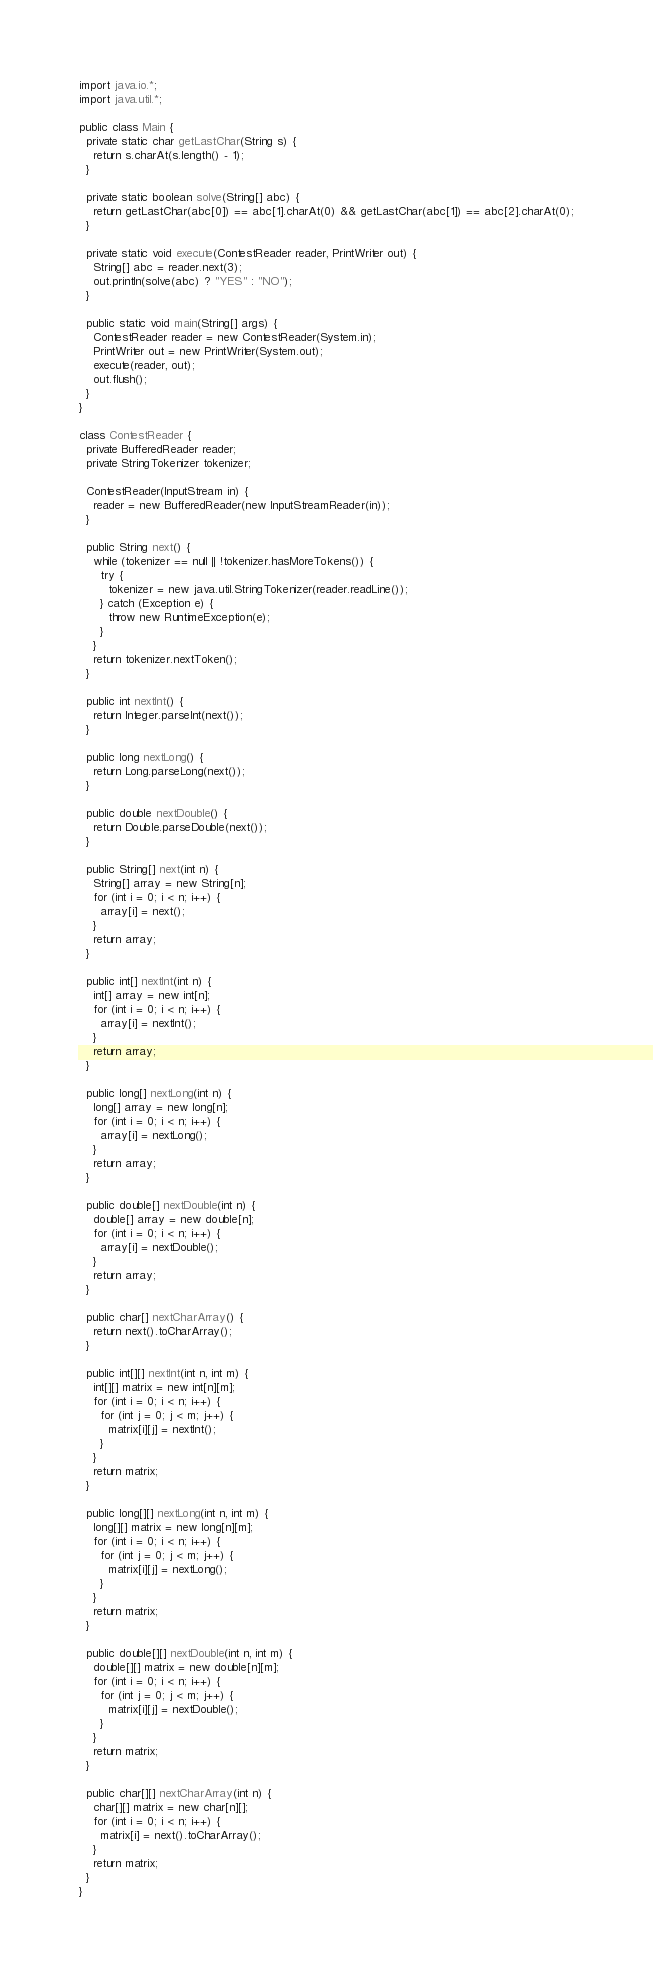<code> <loc_0><loc_0><loc_500><loc_500><_Java_>import java.io.*;
import java.util.*;

public class Main {
  private static char getLastChar(String s) {
    return s.charAt(s.length() - 1);
  }
  
  private static boolean solve(String[] abc) {
    return getLastChar(abc[0]) == abc[1].charAt(0) && getLastChar(abc[1]) == abc[2].charAt(0);
  }
  
  private static void execute(ContestReader reader, PrintWriter out) {
    String[] abc = reader.next(3);
    out.println(solve(abc) ? "YES" : "NO");
  }
  
  public static void main(String[] args) {
    ContestReader reader = new ContestReader(System.in);
    PrintWriter out = new PrintWriter(System.out);
    execute(reader, out);
    out.flush();
  }
}

class ContestReader {
  private BufferedReader reader;
  private StringTokenizer tokenizer;
  
  ContestReader(InputStream in) {
    reader = new BufferedReader(new InputStreamReader(in));
  }
  
  public String next() {
    while (tokenizer == null || !tokenizer.hasMoreTokens()) {
      try {
        tokenizer = new java.util.StringTokenizer(reader.readLine());
      } catch (Exception e) {
        throw new RuntimeException(e);
      }
    }
    return tokenizer.nextToken();
  }
  
  public int nextInt() {
    return Integer.parseInt(next());
  }
  
  public long nextLong() {
    return Long.parseLong(next());
  }
  
  public double nextDouble() {
    return Double.parseDouble(next());
  }
  
  public String[] next(int n) {
    String[] array = new String[n];
    for (int i = 0; i < n; i++) {
      array[i] = next();
    }
    return array;
  }
  
  public int[] nextInt(int n) {
    int[] array = new int[n];
    for (int i = 0; i < n; i++) {
      array[i] = nextInt();
    }
    return array;
  }
  
  public long[] nextLong(int n) {
    long[] array = new long[n];
    for (int i = 0; i < n; i++) {
      array[i] = nextLong();
    }
    return array;
  }
  
  public double[] nextDouble(int n) {
    double[] array = new double[n];
    for (int i = 0; i < n; i++) {
      array[i] = nextDouble();
    }
    return array;
  }
  
  public char[] nextCharArray() {
    return next().toCharArray();
  }
  
  public int[][] nextInt(int n, int m) {
    int[][] matrix = new int[n][m];
    for (int i = 0; i < n; i++) {
      for (int j = 0; j < m; j++) {
        matrix[i][j] = nextInt();
      }
    }
    return matrix;
  }
  
  public long[][] nextLong(int n, int m) {
    long[][] matrix = new long[n][m];
    for (int i = 0; i < n; i++) {
      for (int j = 0; j < m; j++) {
        matrix[i][j] = nextLong();
      }
    }
    return matrix;
  }
  
  public double[][] nextDouble(int n, int m) {
    double[][] matrix = new double[n][m];
    for (int i = 0; i < n; i++) {
      for (int j = 0; j < m; j++) {
        matrix[i][j] = nextDouble();
      }
    }
    return matrix;
  }
  
  public char[][] nextCharArray(int n) {
    char[][] matrix = new char[n][];
    for (int i = 0; i < n; i++) {
      matrix[i] = next().toCharArray();
    }
    return matrix;
  }
}
</code> 